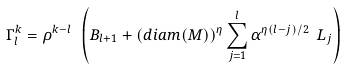<formula> <loc_0><loc_0><loc_500><loc_500>\Gamma _ { l } ^ { k } = \rho ^ { k - l } \ \left ( B _ { l + 1 } + ( d i a m ( M ) ) ^ { \eta } \sum _ { j = 1 } ^ { l } \alpha ^ { \eta ( l - j ) / 2 } \ L _ { j } \right )</formula> 